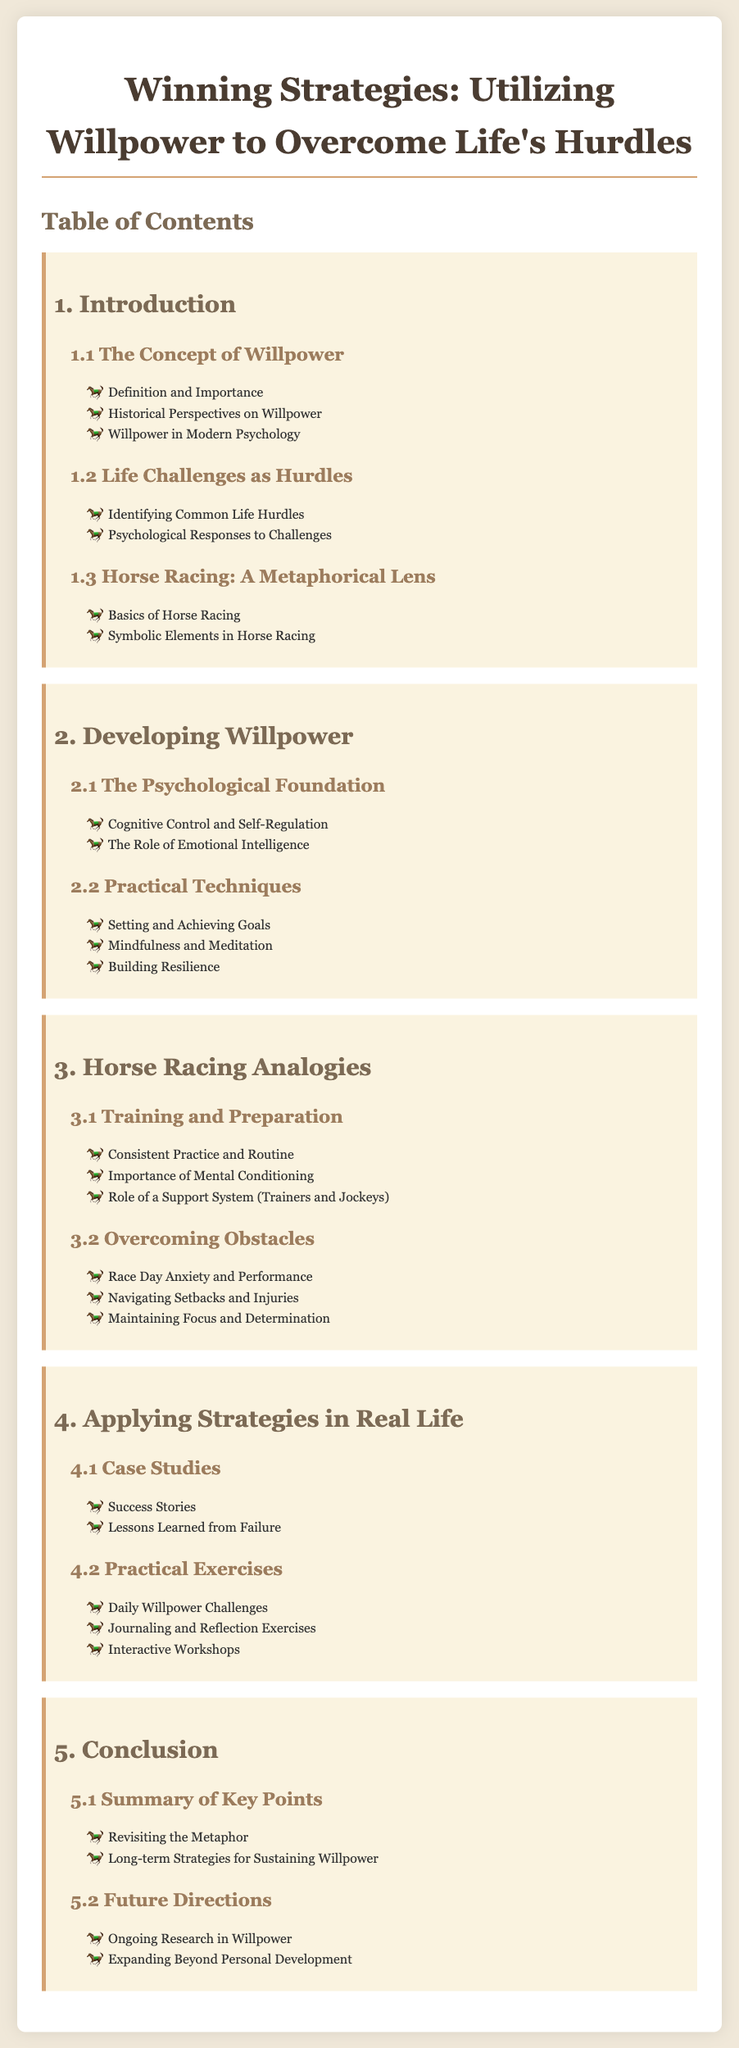What is the title of the document? The title is provided at the top of the rendered document.
Answer: Winning Strategies: Utilizing Willpower to Overcome Life's Hurdles How many main sections are in the Table of Contents? The main sections are listed numerically in the Table of Contents.
Answer: 5 What is discussed in section 1.1? Section 1.1 contains subsections related to the concept of willpower.
Answer: The Concept of Willpower What metaphor is used throughout the document? The document explicitly states a metaphor that is central to understanding the material.
Answer: Horse Racing What practical technique is mentioned in section 2.2? Section 2.2 consists of a list of techniques for developing willpower.
Answer: Mindfulness and Meditation Which section contains case studies? The document organizes case studies in a specific section that provides examples.
Answer: Section 4.1 What is the focus of section 3.2? Section 3.2 outlines themes and challenges related to overcoming obstacles.
Answer: Overcoming Obstacles How many subsections are in the conclusion? The conclusion is broken down into smaller parts that detail its main elements.
Answer: 2 